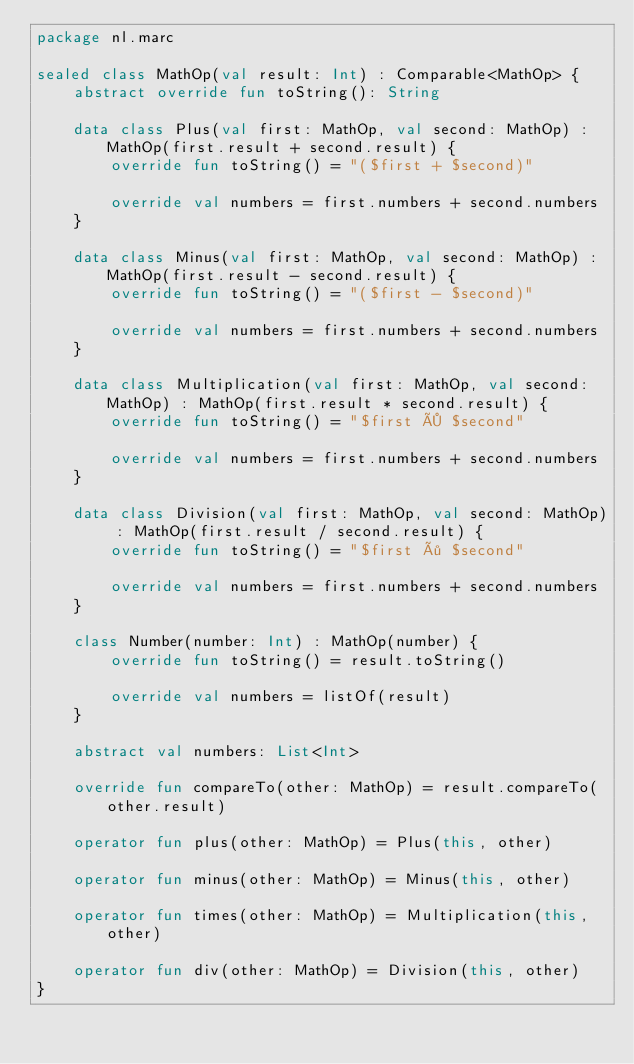<code> <loc_0><loc_0><loc_500><loc_500><_Kotlin_>package nl.marc

sealed class MathOp(val result: Int) : Comparable<MathOp> {
    abstract override fun toString(): String

    data class Plus(val first: MathOp, val second: MathOp) : MathOp(first.result + second.result) {
        override fun toString() = "($first + $second)"

        override val numbers = first.numbers + second.numbers
    }

    data class Minus(val first: MathOp, val second: MathOp) : MathOp(first.result - second.result) {
        override fun toString() = "($first - $second)"

        override val numbers = first.numbers + second.numbers
    }

    data class Multiplication(val first: MathOp, val second: MathOp) : MathOp(first.result * second.result) {
        override fun toString() = "$first × $second"

        override val numbers = first.numbers + second.numbers
    }

    data class Division(val first: MathOp, val second: MathOp) : MathOp(first.result / second.result) {
        override fun toString() = "$first ÷ $second"

        override val numbers = first.numbers + second.numbers
    }

    class Number(number: Int) : MathOp(number) {
        override fun toString() = result.toString()

        override val numbers = listOf(result)
    }

    abstract val numbers: List<Int>

    override fun compareTo(other: MathOp) = result.compareTo(other.result)

    operator fun plus(other: MathOp) = Plus(this, other)

    operator fun minus(other: MathOp) = Minus(this, other)

    operator fun times(other: MathOp) = Multiplication(this, other)

    operator fun div(other: MathOp) = Division(this, other)
}</code> 